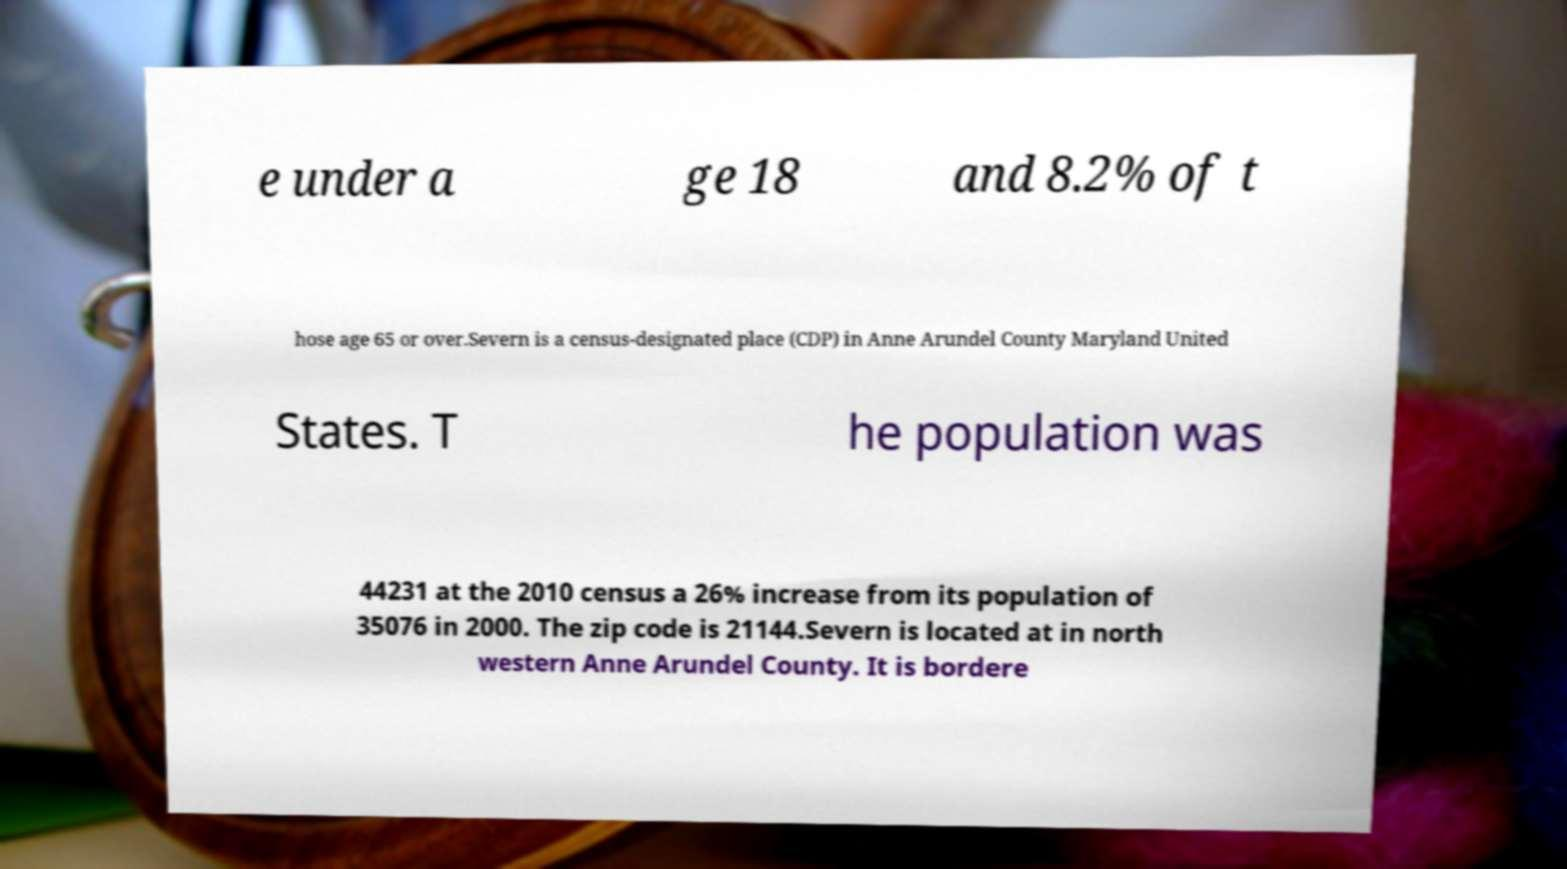For documentation purposes, I need the text within this image transcribed. Could you provide that? e under a ge 18 and 8.2% of t hose age 65 or over.Severn is a census-designated place (CDP) in Anne Arundel County Maryland United States. T he population was 44231 at the 2010 census a 26% increase from its population of 35076 in 2000. The zip code is 21144.Severn is located at in north western Anne Arundel County. It is bordere 